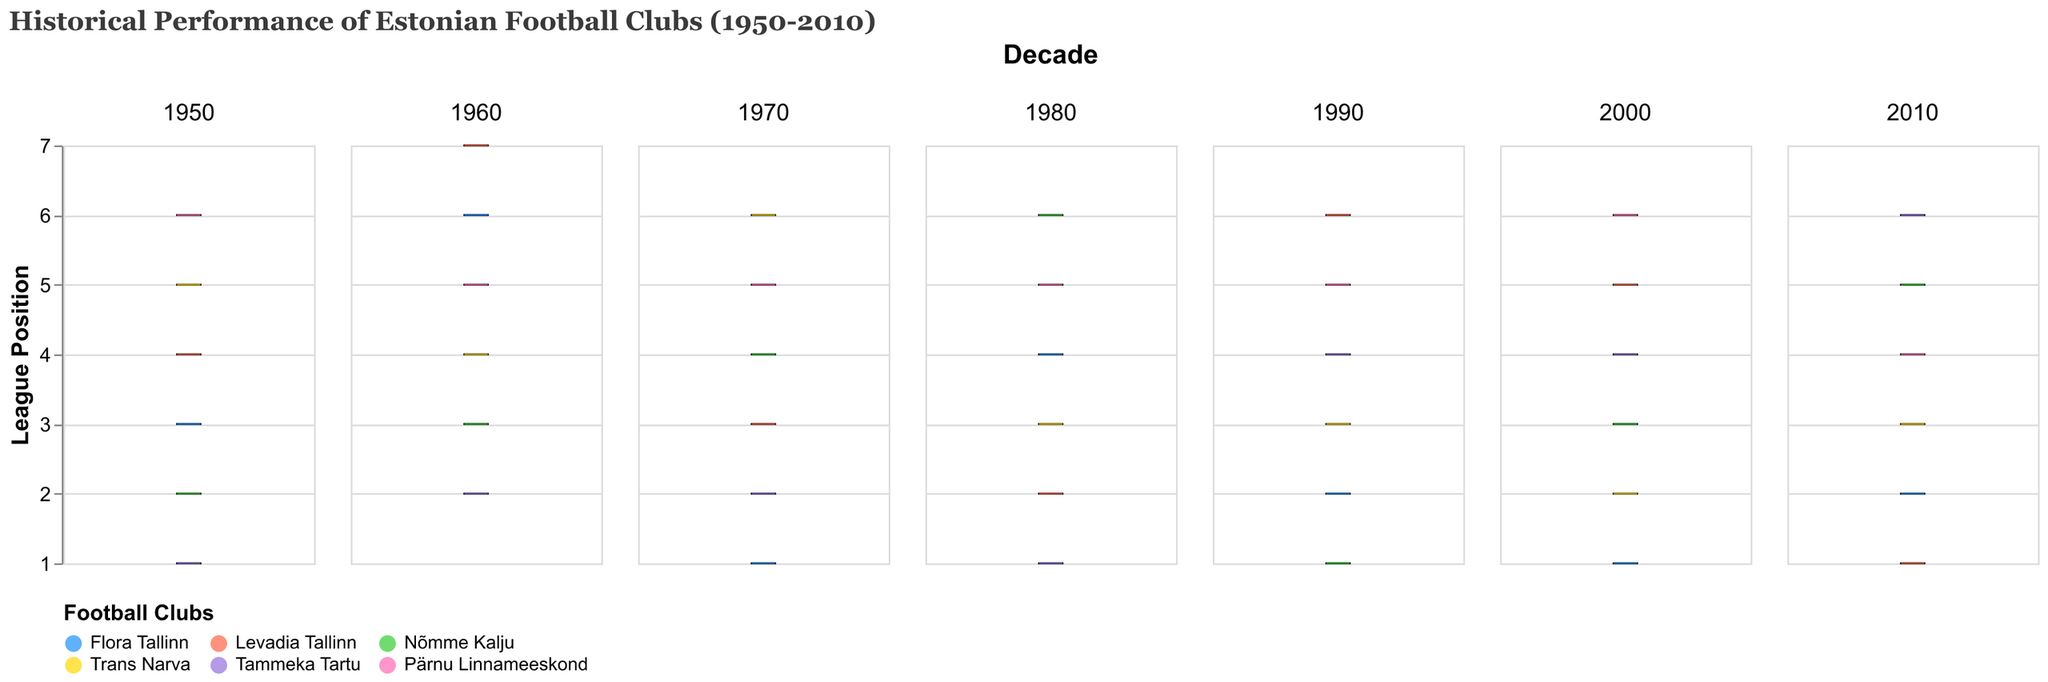Which football club has the highest performance in the 1960 season? In the 1960 season plot, the football club with the highest performance will have the smallest number since higher performance is indicated by lower league positions. The lowest value in the 1960 plot is for Tammeka Tartu.
Answer: Tammeka Tartu Which decade shows the highest variability in performance across clubs? Variability in the performance can be observed by the spread of the box plot. The decade with the greatest spread in performance values is 1960, ranging from rank 2 to 7.
Answer: 1960 Which club appears the most frequently at the first position over the decades? By observing the median lines closest to 1 in each subplot, we find Flora Tallinn appeared at the first position in 1970, 2000, and 2010, which is more often than any other clubs.
Answer: Flora Tallinn What was the median performance of Nõmme Kalju in the 1990s? The median in a box plot is represented by a line within the box. For Nõmme Kalju in the 1990s, the median line within the box plot aligns with position 1.
Answer: 1 Which decade had the smallest interquartile range (IQR) for Trans Narva? The IQR is represented by the length of the box. By comparing the box lengths for Trans Narva in all decades, we find that the 1990s have the smallest box indicating the smallest IQR.
Answer: 1990 How did Levadia Tallinn's performance trend change between 1980 and 2000? In 1980, Levadia Tallinn’s median position was 2 and by 2000, it changed to 5 indicating a decline in performance over the decades.
Answer: Declined Was Pärnu Linnameeskond ever in the top 3 positions across any decades? Looking through each subplot, Pärnu Linnameeskond is always positioned at 4 or higher in the subsequent decades, thus it was never in the top 3.
Answer: No Which club had the least consistent performance in the 1970s? Consistency can be measured by the spread of the performance values. In the 1970s boxplot, Trans Narva has the greatest spread ranging from position 2 to 6, indicating the least consistency.
Answer: Trans Narva 